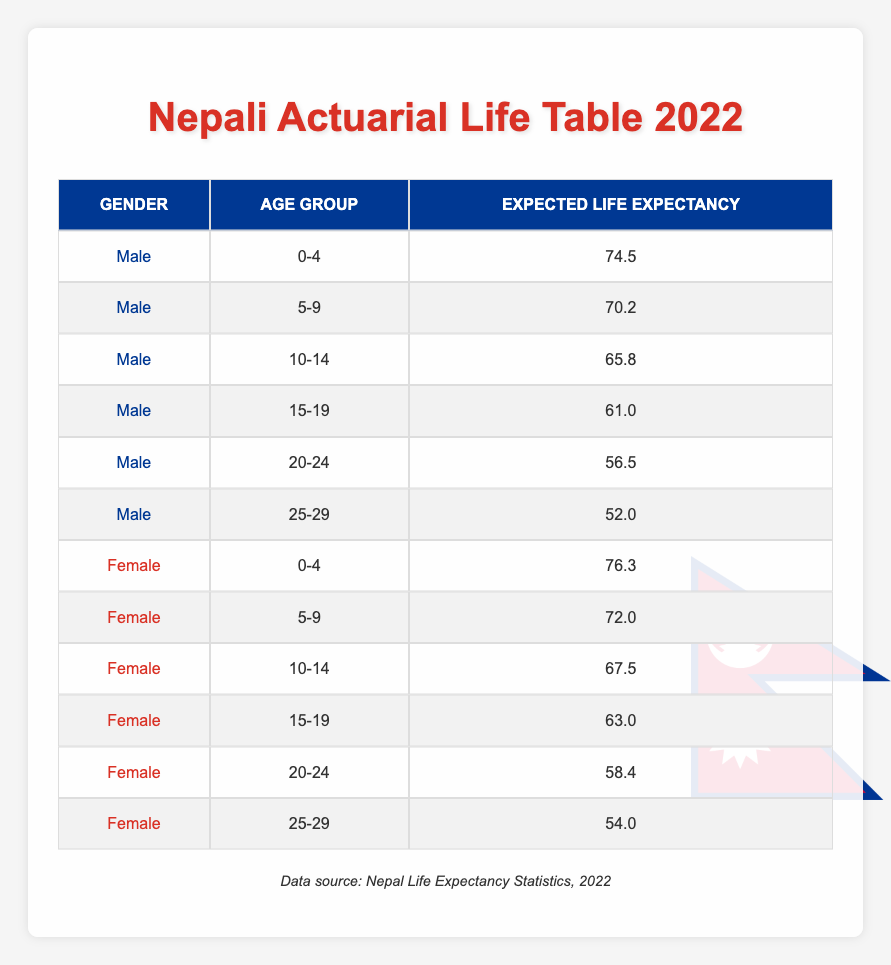What is the expected life expectancy for Nepali males aged 0-4? According to the table, the life expectancy for Nepali males in the age group 0-4 is listed directly as 74.5 years.
Answer: 74.5 What is the expected life expectancy for Nepali females aged 15-19? From the table, the life expectancy for Nepali females in the age group 15-19 is given as 63.0 years.
Answer: 63.0 How do the expected life expectancies of males and females in the age group 20-24 compare? The life expectancy for males aged 20-24 is 56.5 years, while for females it is 58.4 years. Females have a higher life expectancy by 1.9 years (58.4 - 56.5 = 1.9).
Answer: Females have a higher life expectancy by 1.9 years What is the average expected life expectancy for the male age groups listed? The life expectancies for males are 74.5, 70.2, 65.8, 61.0, 56.5, and 52.0. Adding these values gives 74.5 + 70.2 + 65.8 + 61.0 + 56.5 + 52.0 = 390. The average is calculated by dividing the total by the number of groups, which is 6. Hence, 390 / 6 = 65.0 years.
Answer: 65.0 Is it true that the expected life expectancy for females is higher than that of males for all age groups listed? By examining the table, we find that for age groups 0-4, 5-9, and 10-14, females have higher life expectancies. However, in the age groups 20-24 and 25-29, males have a lower life expectancy, revealing that the statement is false.
Answer: No What age group has the highest expected life expectancy for females? The table shows that females aged 0-4 have the highest expected life expectancy at 76.3 years, compared to other age groups.
Answer: 0-4 Calculate the difference in expected life expectancy between the age groups 5-9 and 15-19 for females. The expected life expectancy for females aged 5-9 is 72.0 years, and for 15-19 it is 63.0 years. The difference is calculated as 72.0 - 63.0 = 9.0 years.
Answer: 9.0 What is the expected life expectancy for Nepali citizens aged 25-29 regardless of gender? For males aged 25-29, the life expectancy is 52.0 years, and for females, it is 54.0 years. The expected life expectancy considering both genders is found by averaging these values: (52.0 + 54.0) / 2 = 53.0 years.
Answer: 53.0 Which age group for males has the lowest expected life expectancy? Looking at the table, for males, the age group 25-29 has the lowest expected life expectancy of 52.0 years compared to the other age groups listed.
Answer: 25-29 